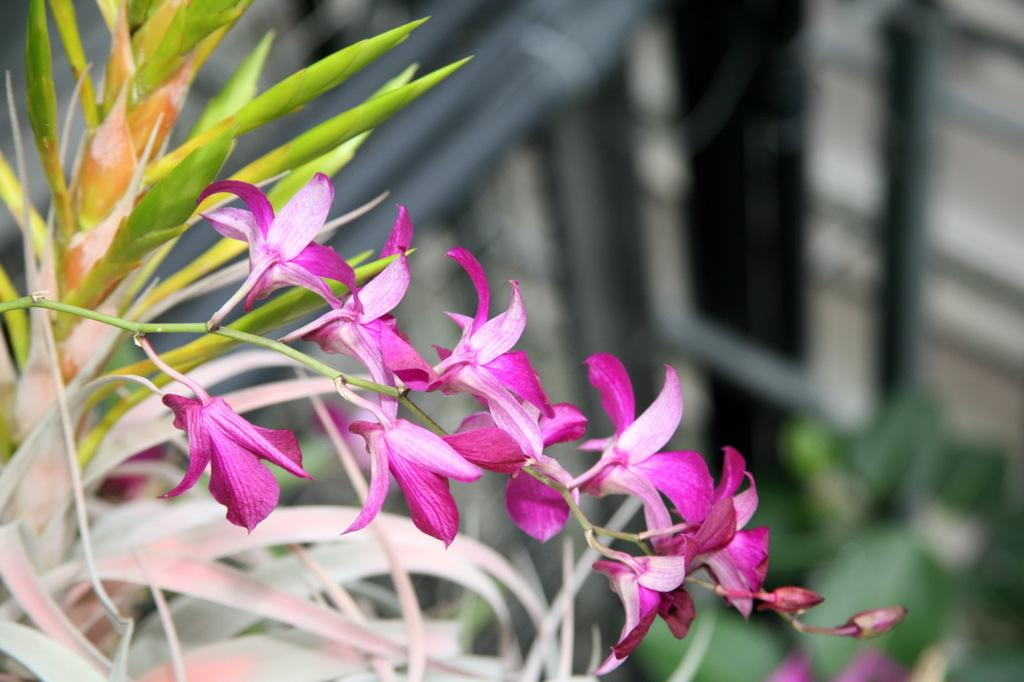What type of plant is visible in the image? The image features a plant with flowers on its stem. Can you describe the flowers on the plant? The flowers are visible on the stem of the plant. What scientific theory is being discussed in the image? There is no discussion or reference to any scientific theory in the image; it simply features a plant with flowers on its stem. 